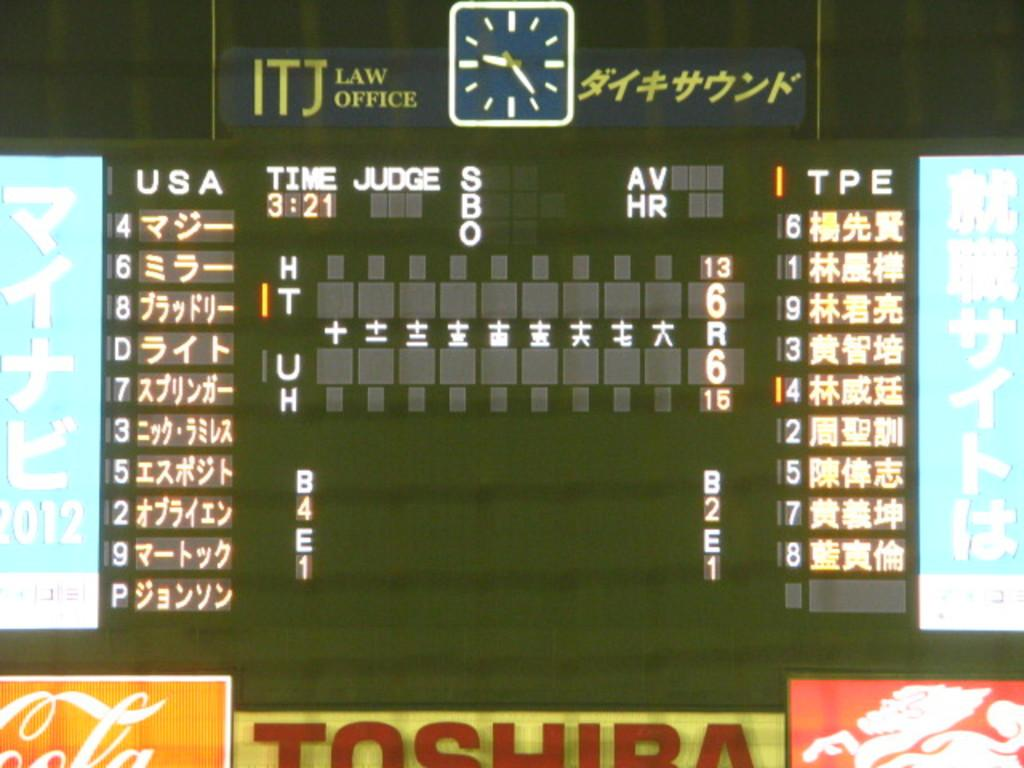Provide a one-sentence caption for the provided image. Number 4 is leading off for team USA. 